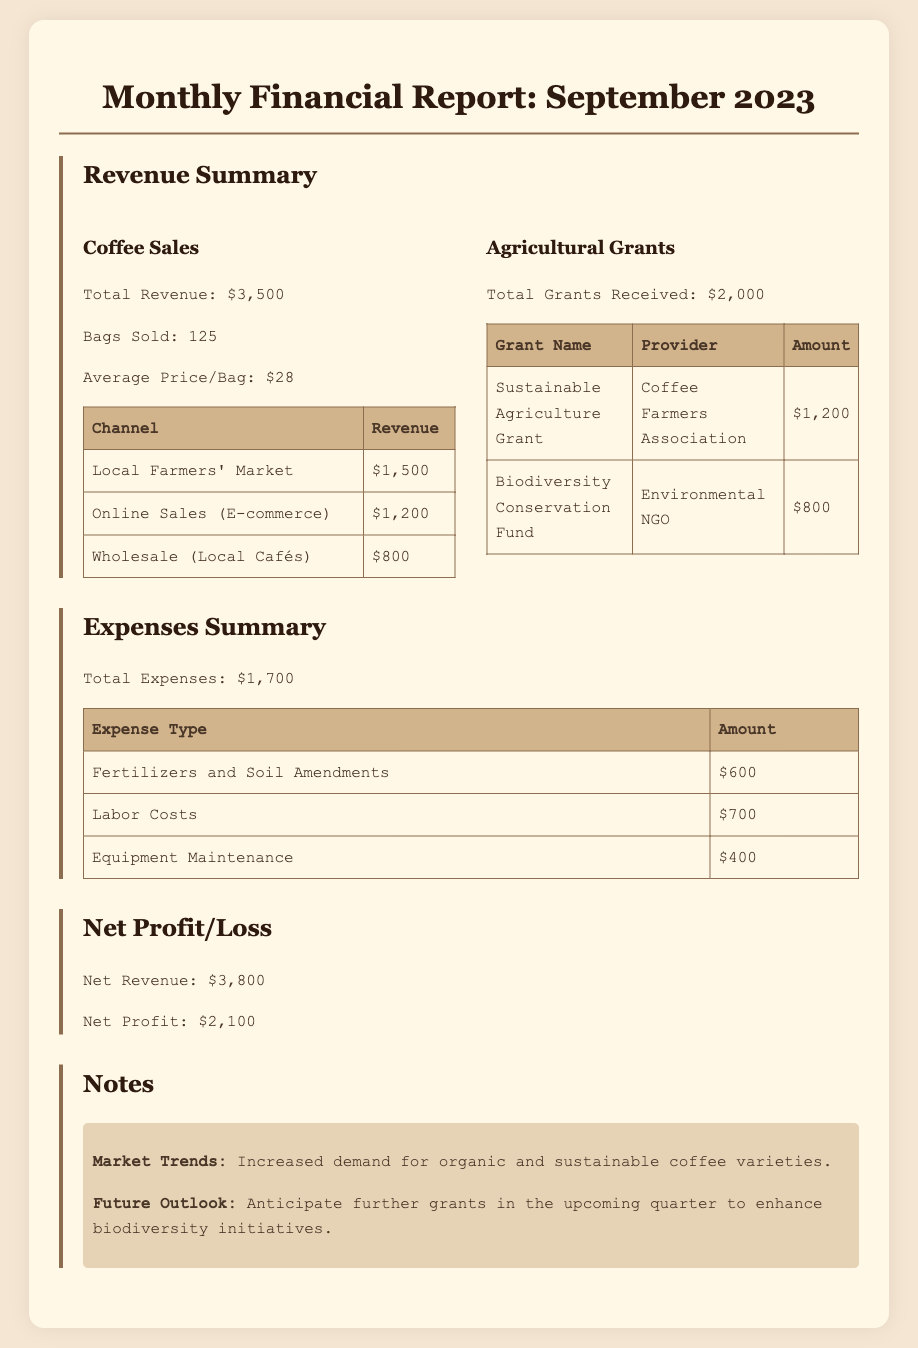What is the total revenue from coffee sales? The document states the total revenue from coffee sales is $3,500.
Answer: $3,500 How many bags of coffee were sold? According to the report, the number of bags sold is 125.
Answer: 125 What is the average price per bag of coffee? The average price per bag, as mentioned in the revenue summary, is $28.
Answer: $28 What amount was received from the Sustainable Agriculture Grant? The document indicates that the amount received from the Sustainable Agriculture Grant is $1,200.
Answer: $1,200 What were the total expenses for the month? The total expenses, as summarized in the expenses section, are $1,700.
Answer: $1,700 What is the net profit for September 2023? The net profit for September 2023 is stated as $2,100.
Answer: $2,100 What is the main market trend mentioned in the report? The document highlights the increased demand for organic and sustainable coffee varieties as a main market trend.
Answer: Increased demand for organic and sustainable coffee varieties What type of grants were received? The report mentions receiving the Sustainable Agriculture Grant and the Biodiversity Conservation Fund.
Answer: Sustainable Agriculture Grant and Biodiversity Conservation Fund How much did labor costs amount to? The total amount spent on labor costs is reported as $700.
Answer: $700 